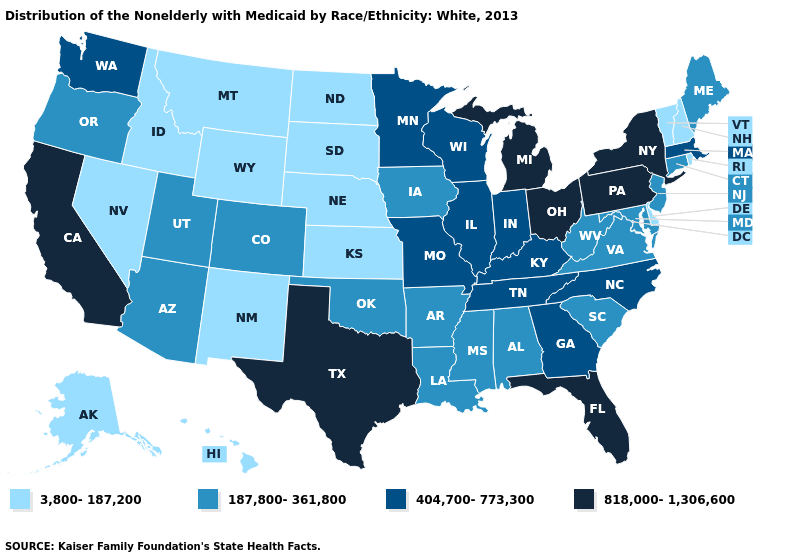What is the lowest value in states that border Texas?
Keep it brief. 3,800-187,200. What is the value of Wisconsin?
Write a very short answer. 404,700-773,300. Does New York have the highest value in the USA?
Write a very short answer. Yes. Name the states that have a value in the range 3,800-187,200?
Give a very brief answer. Alaska, Delaware, Hawaii, Idaho, Kansas, Montana, Nebraska, Nevada, New Hampshire, New Mexico, North Dakota, Rhode Island, South Dakota, Vermont, Wyoming. Name the states that have a value in the range 3,800-187,200?
Be succinct. Alaska, Delaware, Hawaii, Idaho, Kansas, Montana, Nebraska, Nevada, New Hampshire, New Mexico, North Dakota, Rhode Island, South Dakota, Vermont, Wyoming. Among the states that border Arizona , which have the highest value?
Be succinct. California. Which states have the lowest value in the Northeast?
Keep it brief. New Hampshire, Rhode Island, Vermont. Name the states that have a value in the range 3,800-187,200?
Be succinct. Alaska, Delaware, Hawaii, Idaho, Kansas, Montana, Nebraska, Nevada, New Hampshire, New Mexico, North Dakota, Rhode Island, South Dakota, Vermont, Wyoming. What is the value of New Hampshire?
Keep it brief. 3,800-187,200. Among the states that border New Hampshire , does Massachusetts have the highest value?
Give a very brief answer. Yes. What is the highest value in the MidWest ?
Concise answer only. 818,000-1,306,600. Name the states that have a value in the range 3,800-187,200?
Quick response, please. Alaska, Delaware, Hawaii, Idaho, Kansas, Montana, Nebraska, Nevada, New Hampshire, New Mexico, North Dakota, Rhode Island, South Dakota, Vermont, Wyoming. Does Minnesota have the highest value in the USA?
Concise answer only. No. Which states have the lowest value in the South?
Answer briefly. Delaware. 